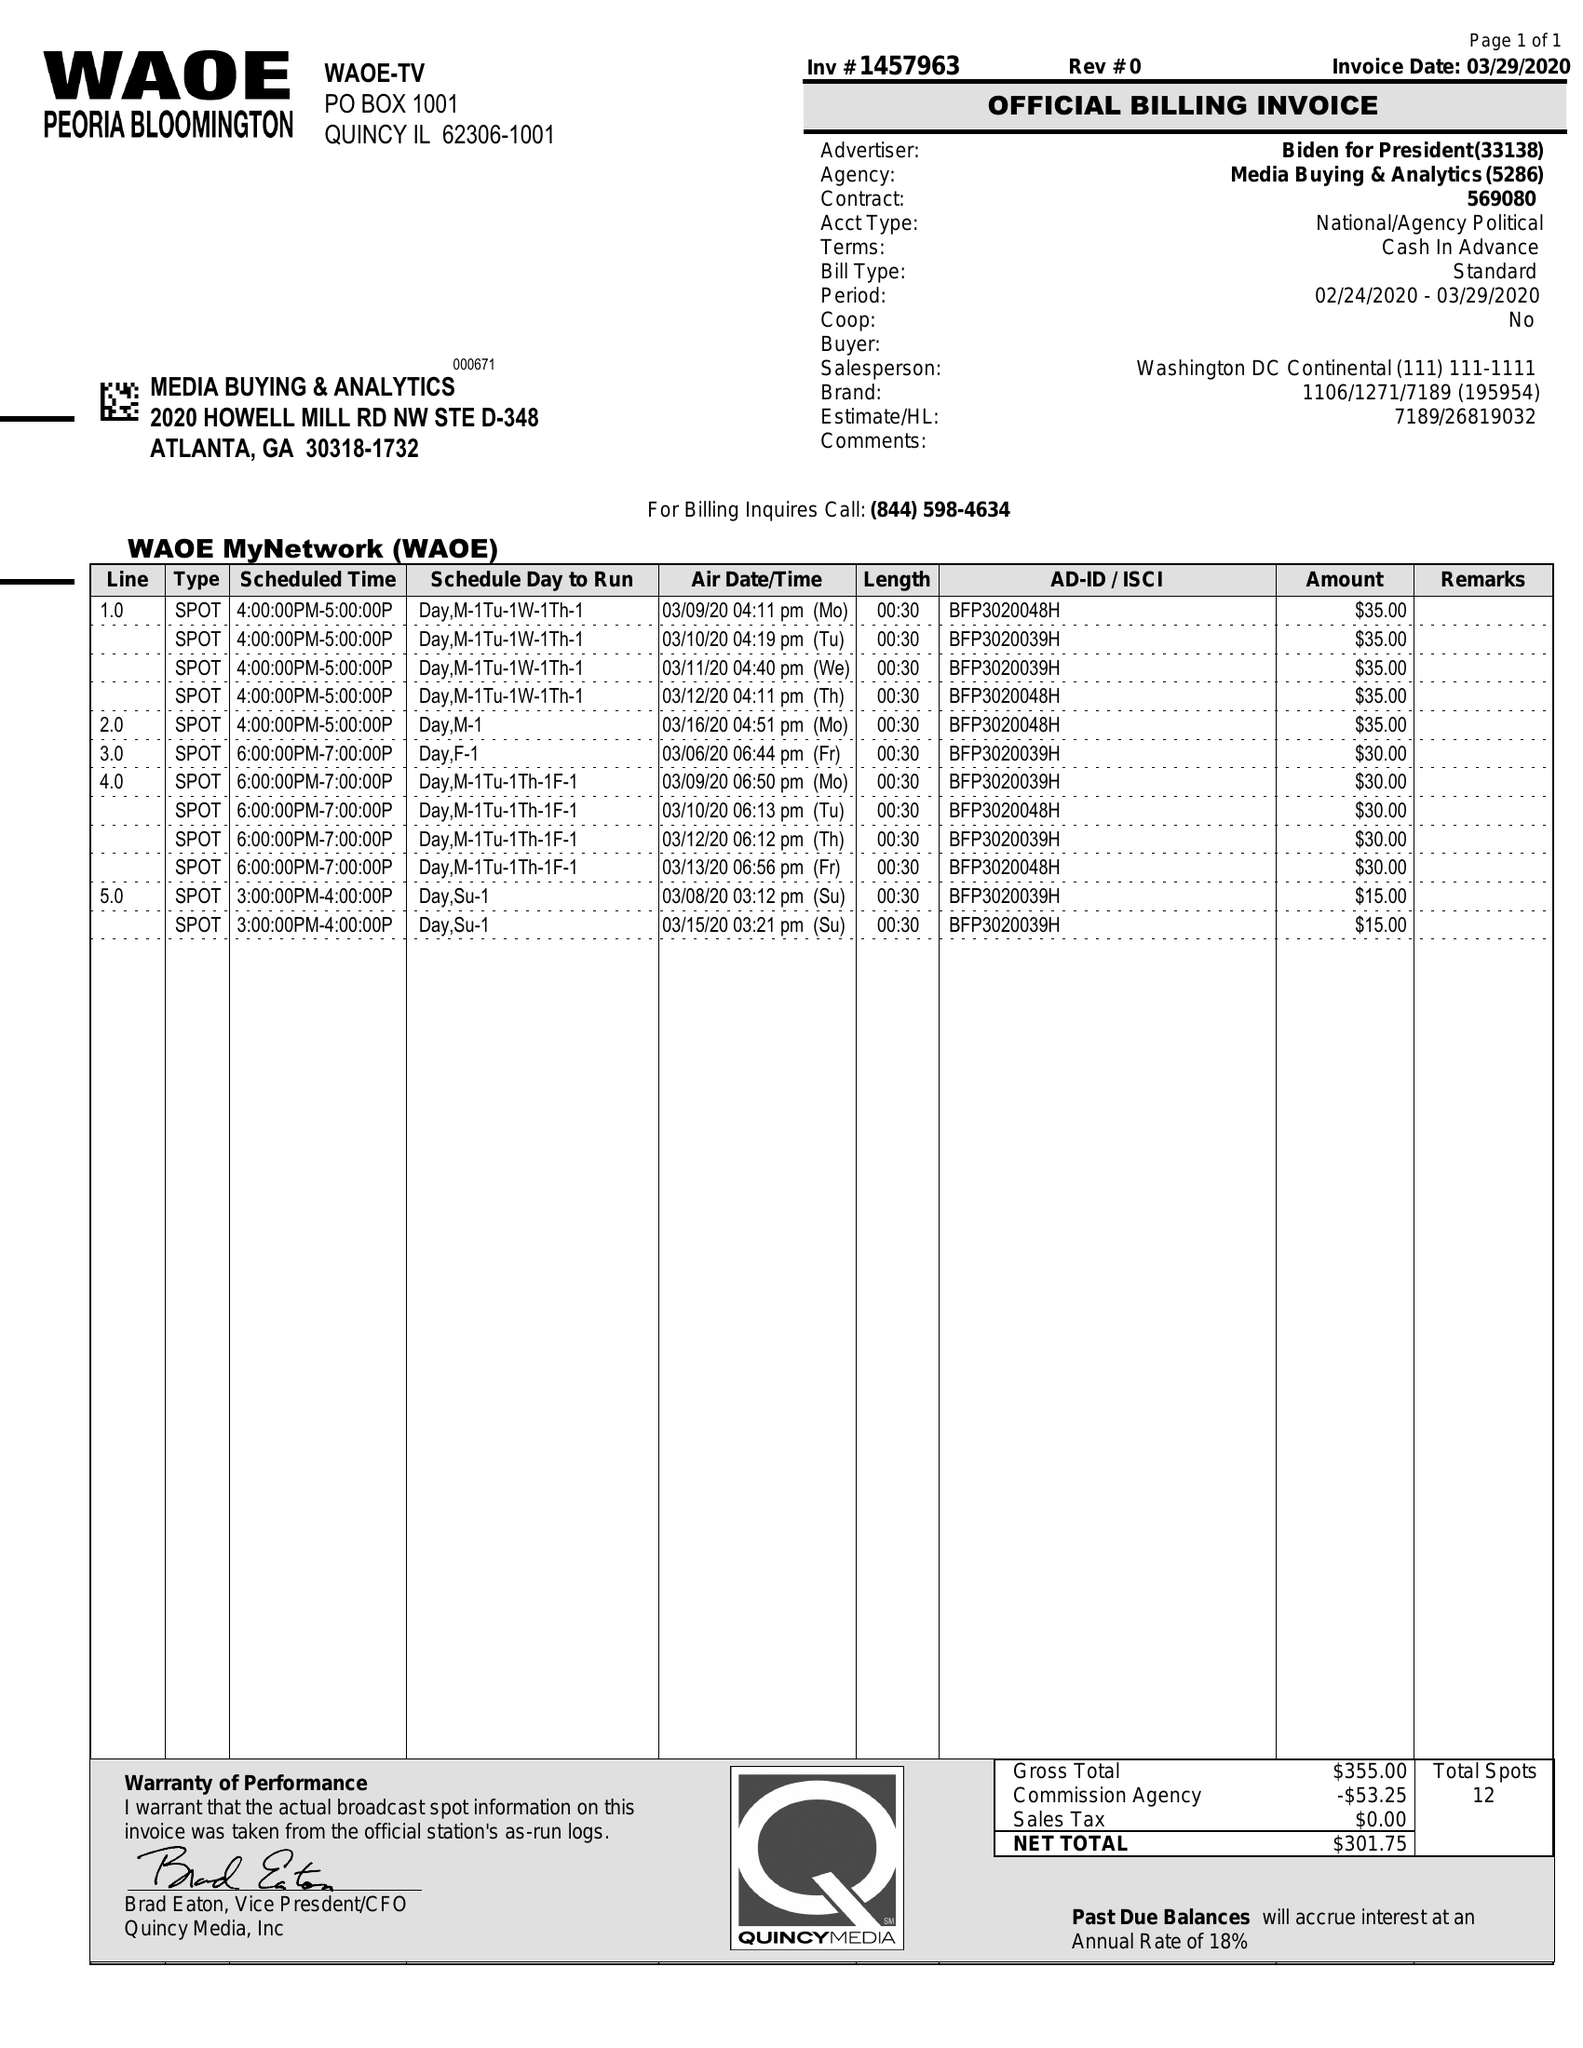What is the value for the advertiser?
Answer the question using a single word or phrase. BIDEN FOR PRESIDENT 